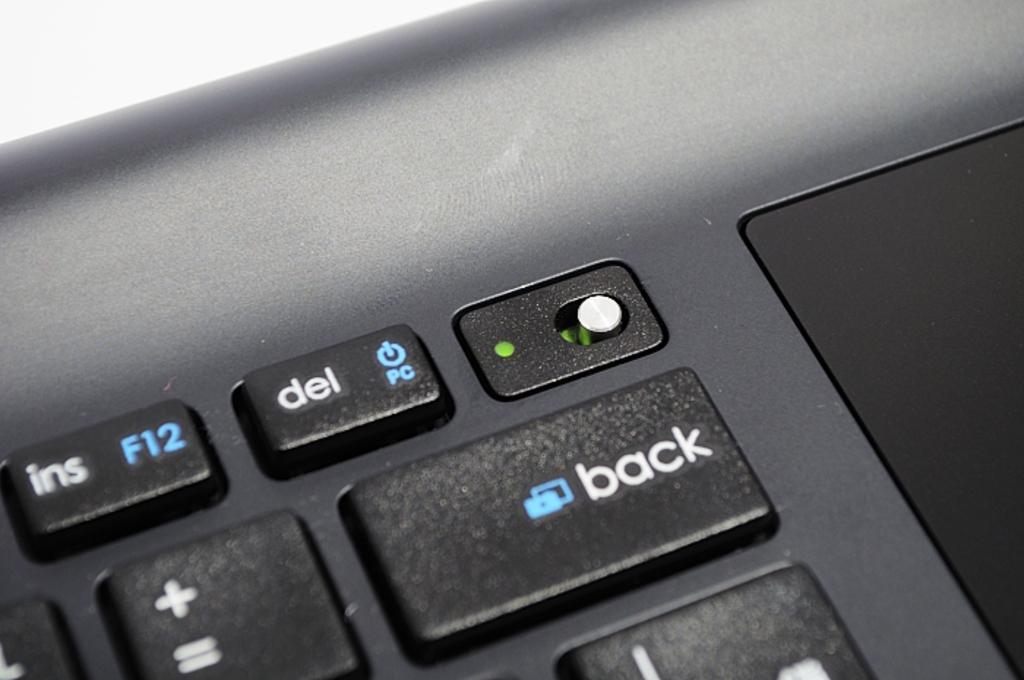Could you give a brief overview of what you see in this image? In the image there are keys of a laptop. 